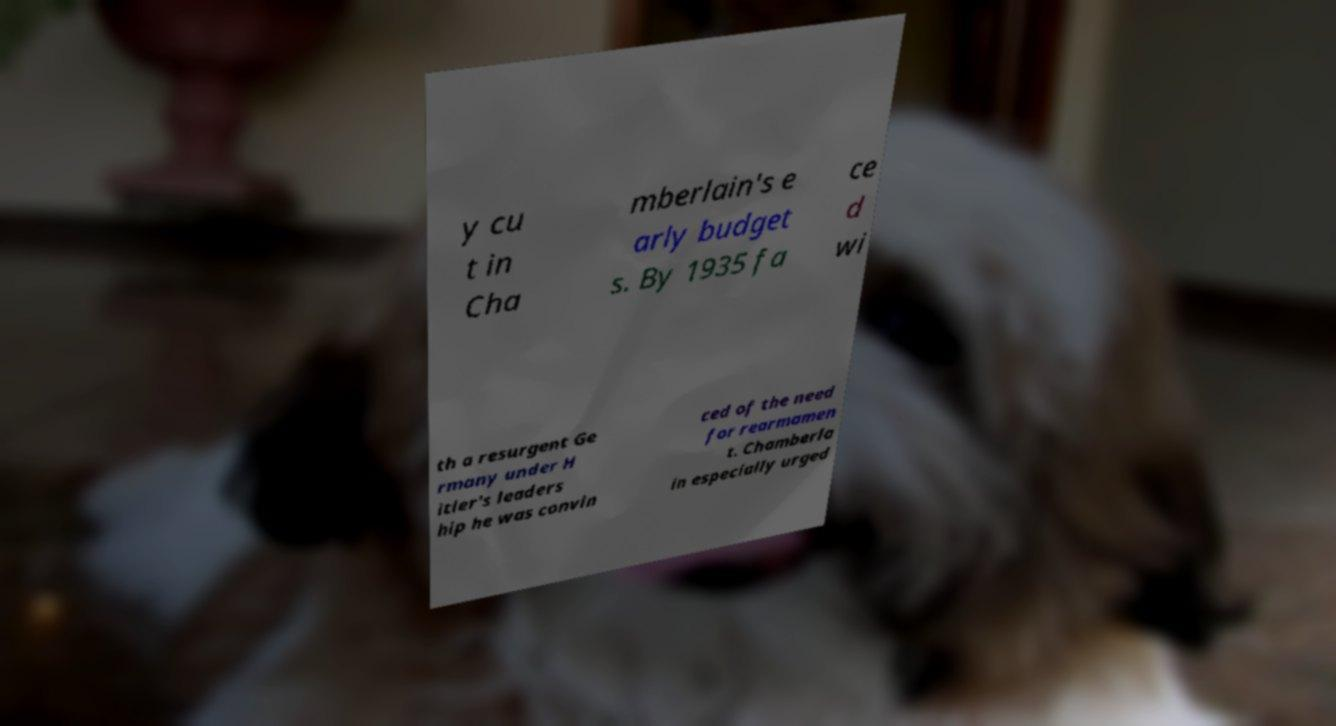I need the written content from this picture converted into text. Can you do that? y cu t in Cha mberlain's e arly budget s. By 1935 fa ce d wi th a resurgent Ge rmany under H itler's leaders hip he was convin ced of the need for rearmamen t. Chamberla in especially urged 